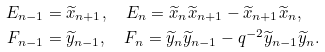Convert formula to latex. <formula><loc_0><loc_0><loc_500><loc_500>E _ { n - 1 } & = \widetilde { x } _ { n + 1 } , \quad E _ { n } = \widetilde { x } _ { n } \widetilde { x } _ { n + 1 } - \widetilde { x } _ { n + 1 } \widetilde { x } _ { n } , \\ F _ { n - 1 } & = \widetilde { y } _ { n - 1 } , \quad F _ { n } = \widetilde { y } _ { n } \widetilde { y } _ { n - 1 } - q ^ { - 2 } \widetilde { y } _ { n - 1 } \widetilde { y } _ { n } .</formula> 